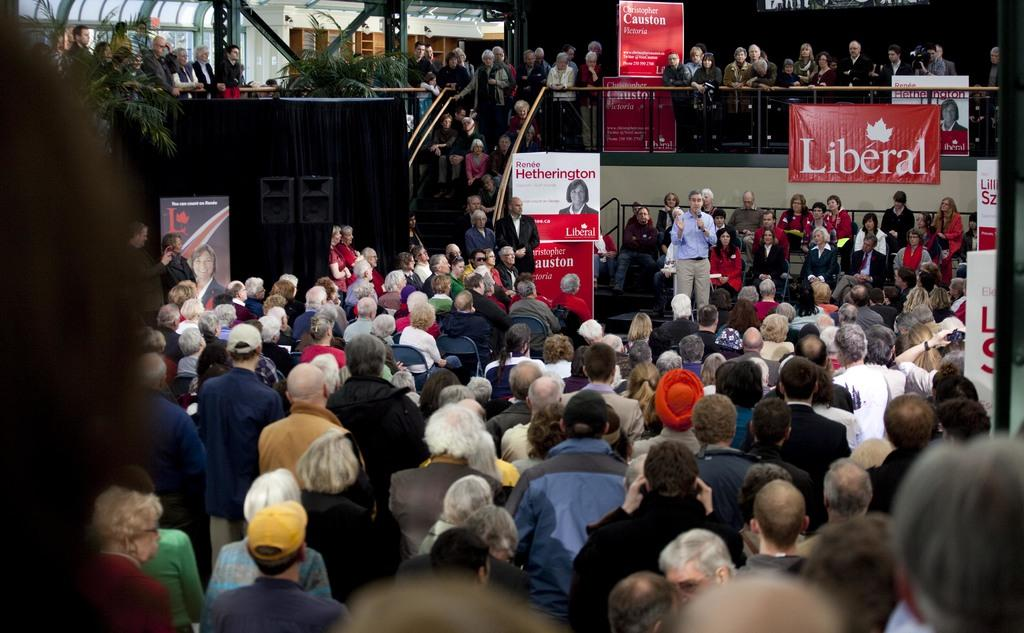What can be seen in the image involving a gathering of individuals? There is a group of people in the image. What type of signage is present in the image? There are banners in the image. What type of structures are visible in the image? There are buildings in the image. What type of natural elements are present in the image? There are plants in the image. What architectural feature is present in the image? There are stairs in the image. What type of hospital can be seen in the image? There is no hospital present in the image. What type of bag is being carried by the people in the image? There is no bag visible in the image. 